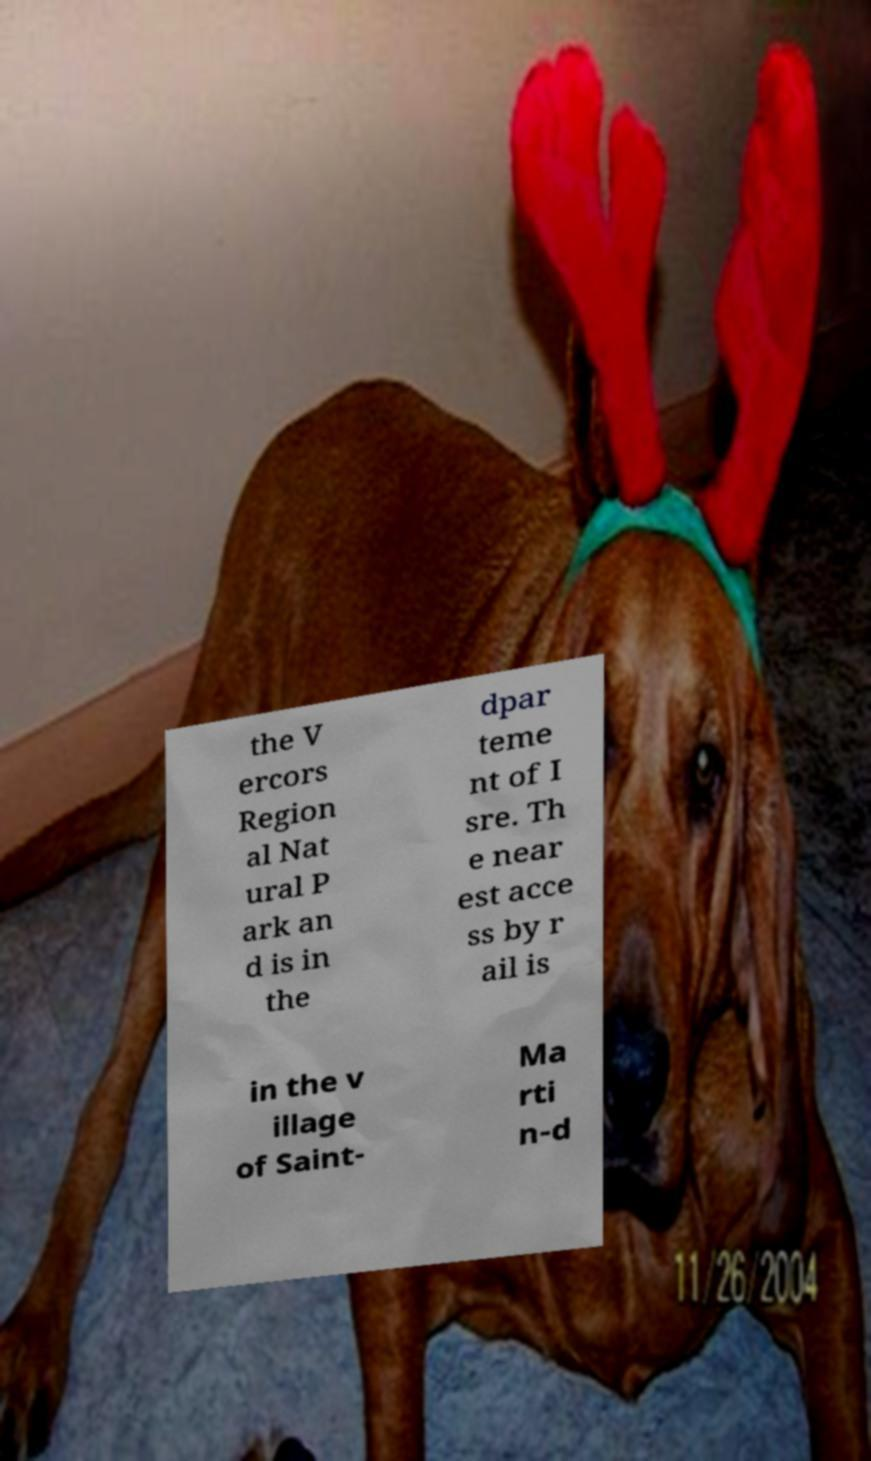What messages or text are displayed in this image? I need them in a readable, typed format. the V ercors Region al Nat ural P ark an d is in the dpar teme nt of I sre. Th e near est acce ss by r ail is in the v illage of Saint- Ma rti n-d 